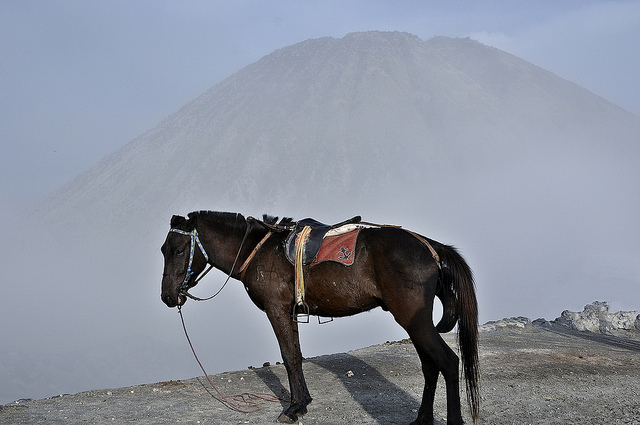What breed of horse is this? Based on the visible characteristics, such as the slender build and the distinct coat, it could possibly be a breed suitable for rough terrains like a Mustang or a similar type. Identifying the exact breed from the image alone is challenging without more distinctive breed markers or additional context on its origin. 